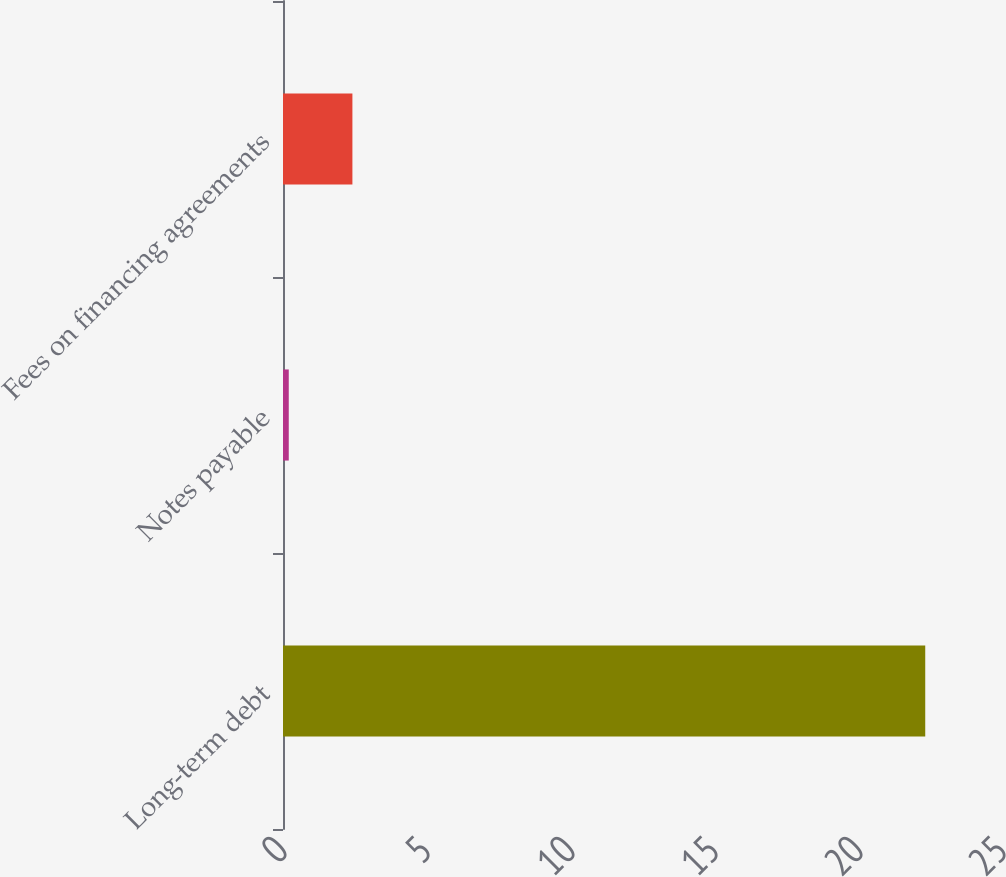<chart> <loc_0><loc_0><loc_500><loc_500><bar_chart><fcel>Long-term debt<fcel>Notes payable<fcel>Fees on financing agreements<nl><fcel>22.3<fcel>0.2<fcel>2.41<nl></chart> 